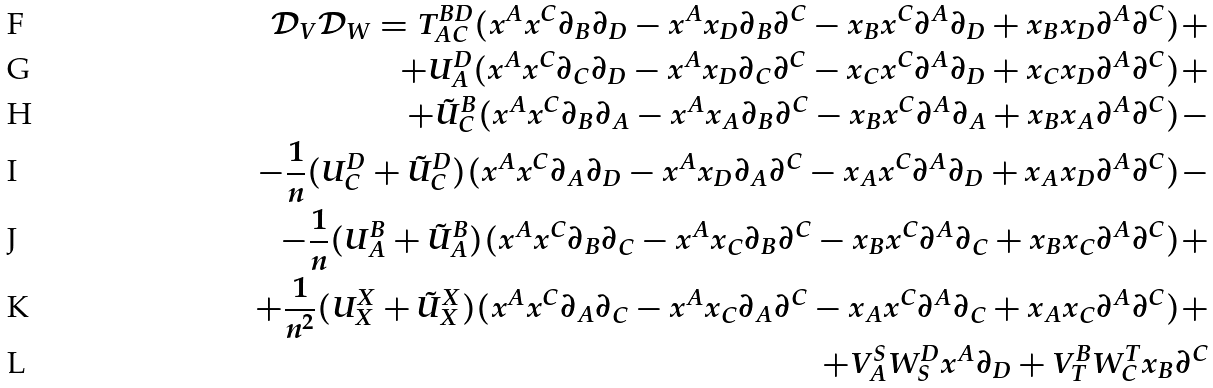Convert formula to latex. <formula><loc_0><loc_0><loc_500><loc_500>\mathcal { D } _ { V } \mathcal { D } _ { W } = T ^ { B D } _ { A C } ( x ^ { A } x ^ { C } \partial _ { B } \partial _ { D } - x ^ { A } x _ { D } \partial _ { B } \partial ^ { C } - x _ { B } x ^ { C } \partial ^ { A } \partial _ { D } + x _ { B } x _ { D } \partial ^ { A } \partial ^ { C } ) + \\ + U ^ { D } _ { A } ( x ^ { A } x ^ { C } \partial _ { C } \partial _ { D } - x ^ { A } x _ { D } \partial _ { C } \partial ^ { C } - x _ { C } x ^ { C } \partial ^ { A } \partial _ { D } + x _ { C } x _ { D } \partial ^ { A } \partial ^ { C } ) + \\ + \tilde { U } ^ { B } _ { C } ( x ^ { A } x ^ { C } \partial _ { B } \partial _ { A } - x ^ { A } x _ { A } \partial _ { B } \partial ^ { C } - x _ { B } x ^ { C } \partial ^ { A } \partial _ { A } + x _ { B } x _ { A } \partial ^ { A } \partial ^ { C } ) - \\ - \frac { 1 } { n } ( U ^ { D } _ { C } + \tilde { U } ^ { D } _ { C } ) ( x ^ { A } x ^ { C } \partial _ { A } \partial _ { D } - x ^ { A } x _ { D } \partial _ { A } \partial ^ { C } - x _ { A } x ^ { C } \partial ^ { A } \partial _ { D } + x _ { A } x _ { D } \partial ^ { A } \partial ^ { C } ) - \\ - \frac { 1 } { n } ( U ^ { B } _ { A } + \tilde { U } ^ { B } _ { A } ) ( x ^ { A } x ^ { C } \partial _ { B } \partial _ { C } - x ^ { A } x _ { C } \partial _ { B } \partial ^ { C } - x _ { B } x ^ { C } \partial ^ { A } \partial _ { C } + x _ { B } x _ { C } \partial ^ { A } \partial ^ { C } ) + \\ + \frac { 1 } { n ^ { 2 } } ( U ^ { X } _ { X } + \tilde { U } ^ { X } _ { X } ) ( x ^ { A } x ^ { C } \partial _ { A } \partial _ { C } - x ^ { A } x _ { C } \partial _ { A } \partial ^ { C } - x _ { A } x ^ { C } \partial ^ { A } \partial _ { C } + x _ { A } x _ { C } \partial ^ { A } \partial ^ { C } ) + \\ + V ^ { S } _ { A } W ^ { D } _ { S } x ^ { A } \partial _ { D } + V ^ { B } _ { T } W ^ { T } _ { C } x _ { B } \partial ^ { C }</formula> 